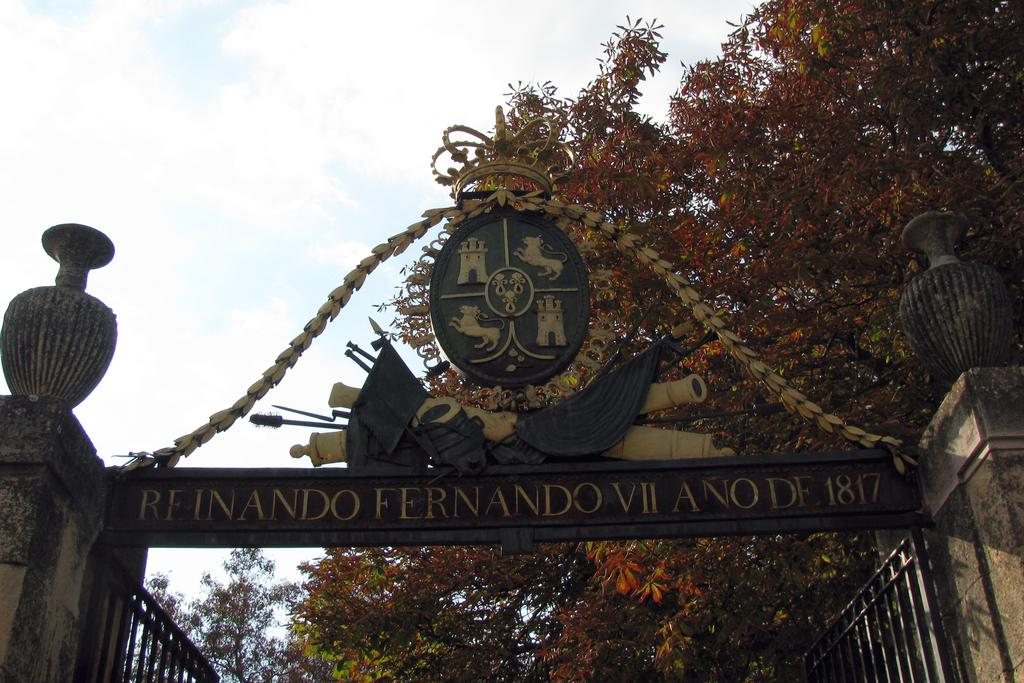Provide a one-sentence caption for the provided image. A steel gate that bears the words reinando fernando VII ano de 1817. 